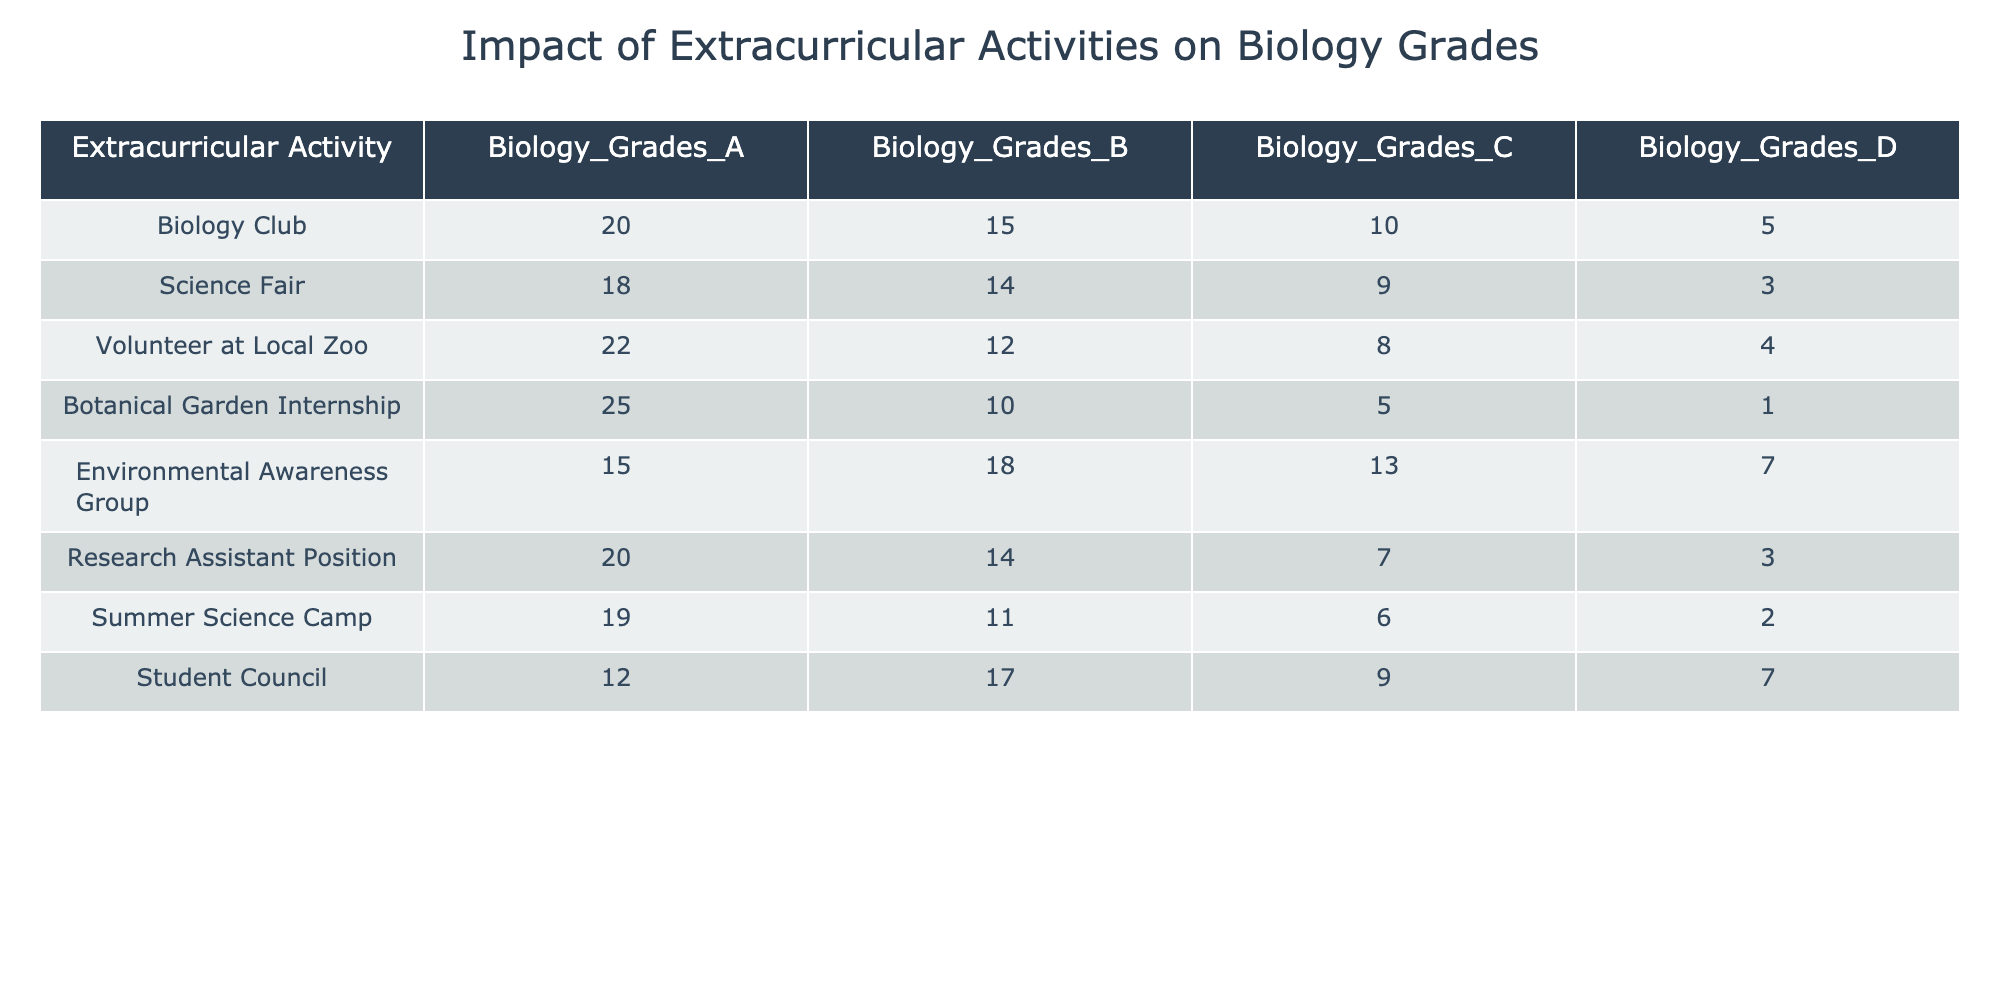What is the highest number of students earning grade A in any extracurricular activity? The table shows that the highest number in the 'Biology Grades A' column is 25, associated with 'Botanical Garden Internship'.
Answer: 25 Which extracurricular activity had the lowest number of students achieving grade D? From the table, 'Botanical Garden Internship' had only 1 student achieving grade D, which is the lowest in that column.
Answer: 1 Which grades did the 'Environmental Awareness Group' help the most students achieve? Looking at the row for 'Environmental Awareness Group', the highest number is in 'Biology Grades B' with 18 students.
Answer: Biology Grades B What is the total number of students earning grade B across all extracurricular activities? To find the total number earning grade B, we sum all values in that column: 15 + 14 + 12 + 10 + 18 + 14 + 11 + 17 = 111.
Answer: 111 Is there an extracurricular activity where no students earned grade C? Checking all rows, each one has at least one number greater than 0 in the 'Biology Grades C' column, indicating that no extracurricular activity had zero students in that grade.
Answer: No What is the average number of students earning grade D across all extracurricular activities? The grade D column has the values: 5, 3, 4, 1, 7, 3, 2, 7. Adding these gives 32, and there are 8 activities, so the average is 32/8 = 4.
Answer: 4 Which extracurricular activity had the most balanced distribution of students across grades A, B, C, and D? To find balance, we compare the differences between the counts in each grade for extracurricular activities. 'Student Council' shows fewer discrepancies among all grades with numbers 12, 17, 9, and 7.
Answer: Student Council What percentage of students participating in 'Research Assistant Position' earned grade A? For 'Research Assistant Position', 20 students earned grade A out of a total of 20 + 14 + 7 + 3 = 44 students. The percentage is (20/44) * 100 = 45.45%.
Answer: 45.45% 